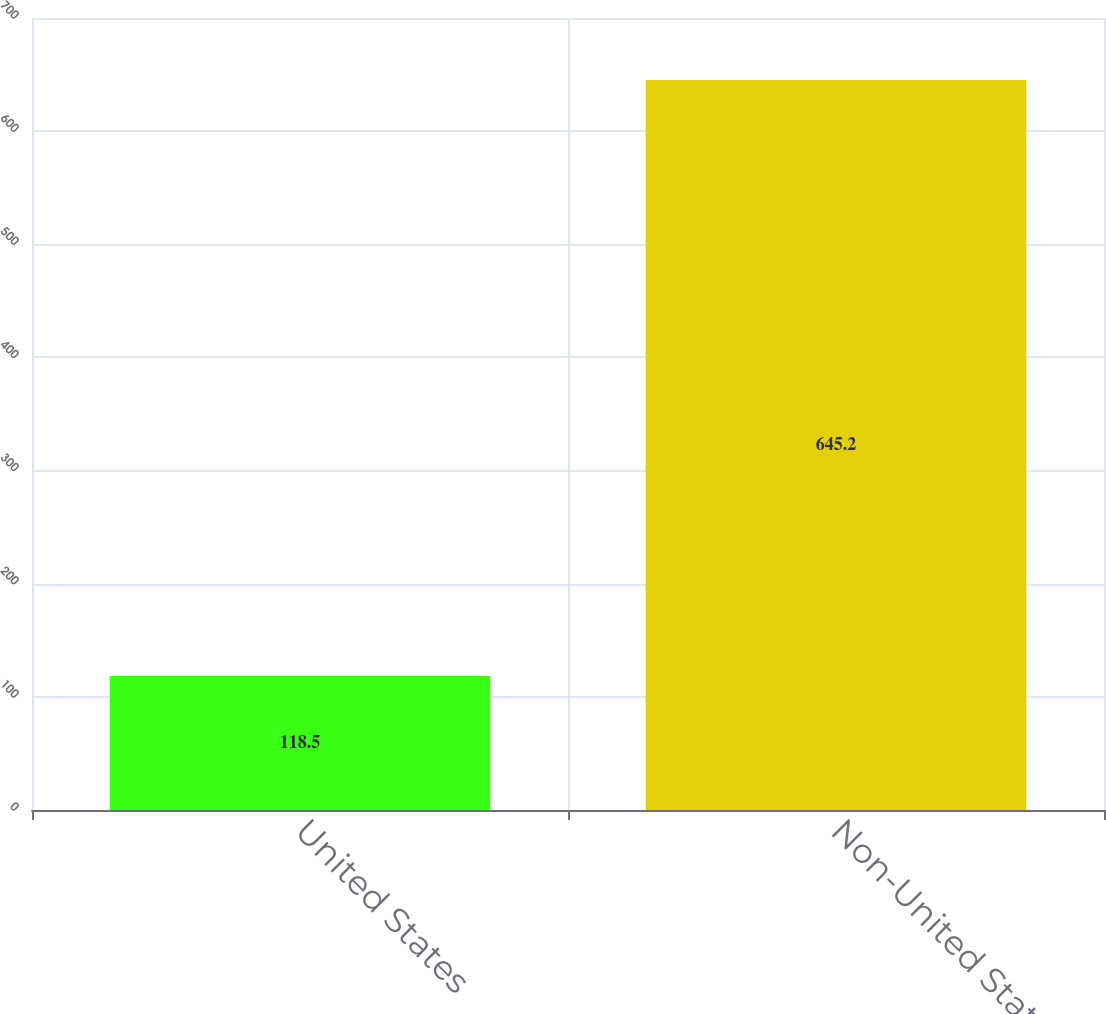Convert chart to OTSL. <chart><loc_0><loc_0><loc_500><loc_500><bar_chart><fcel>United States<fcel>Non-United States<nl><fcel>118.5<fcel>645.2<nl></chart> 